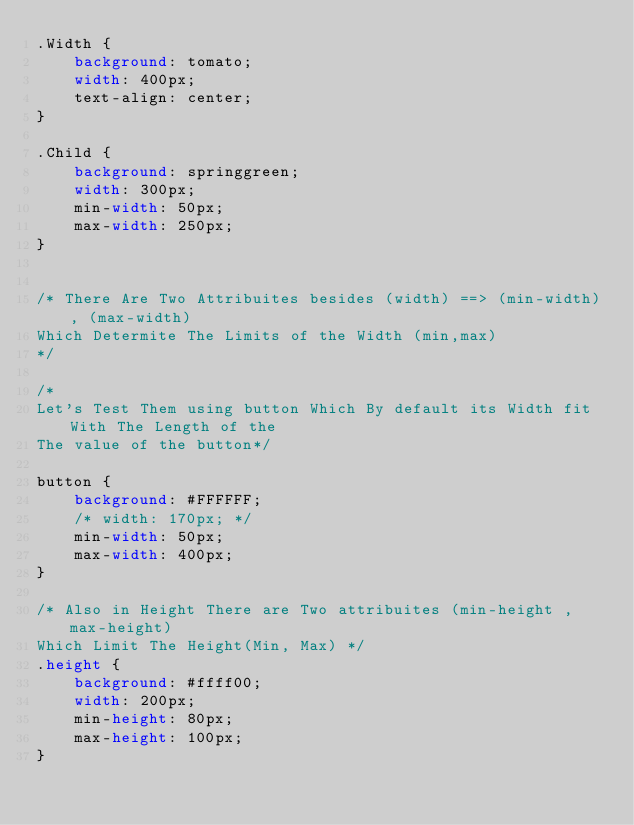Convert code to text. <code><loc_0><loc_0><loc_500><loc_500><_CSS_>.Width {
    background: tomato;
    width: 400px;
    text-align: center;
}

.Child {
    background: springgreen;
    width: 300px;
    min-width: 50px;
    max-width: 250px;
}


/* There Are Two Attribuites besides (width) ==> (min-width), (max-width)
Which Determite The Limits of the Width (min,max)
*/

/* 
Let's Test Them using button Which By default its Width fit With The Length of the 
The value of the button*/

button {
    background: #FFFFFF;
    /* width: 170px; */
    min-width: 50px;
    max-width: 400px;
}

/* Also in Height There are Two attribuites (min-height , max-height)
Which Limit The Height(Min, Max) */
.height {
    background: #ffff00;
    width: 200px;
    min-height: 80px;
    max-height: 100px;
}</code> 